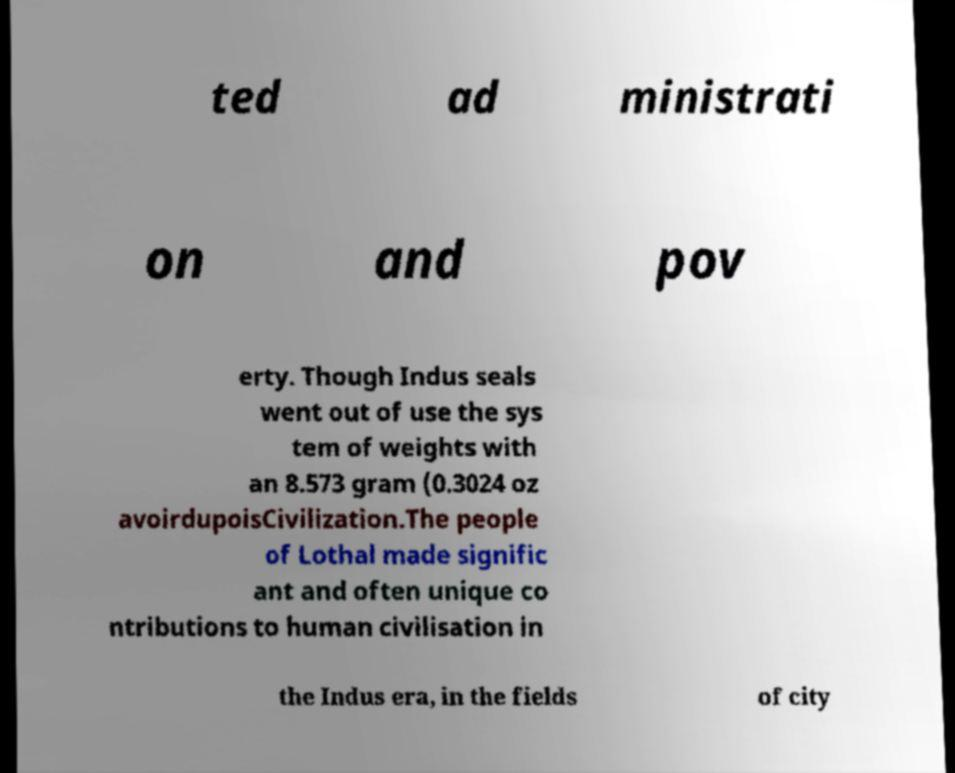Can you read and provide the text displayed in the image?This photo seems to have some interesting text. Can you extract and type it out for me? ted ad ministrati on and pov erty. Though Indus seals went out of use the sys tem of weights with an 8.573 gram (0.3024 oz avoirdupoisCivilization.The people of Lothal made signific ant and often unique co ntributions to human civilisation in the Indus era, in the fields of city 